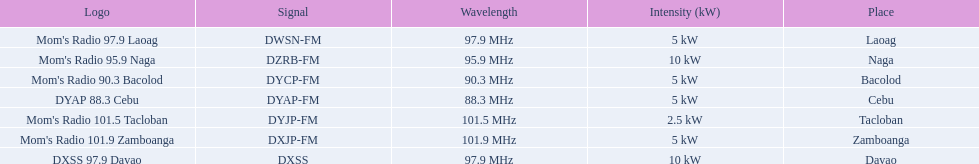What are the frequencies for radios of dyap-fm? 97.9 MHz, 95.9 MHz, 90.3 MHz, 88.3 MHz, 101.5 MHz, 101.9 MHz, 97.9 MHz. What is the lowest frequency? 88.3 MHz. Which radio has this frequency? DYAP 88.3 Cebu. 